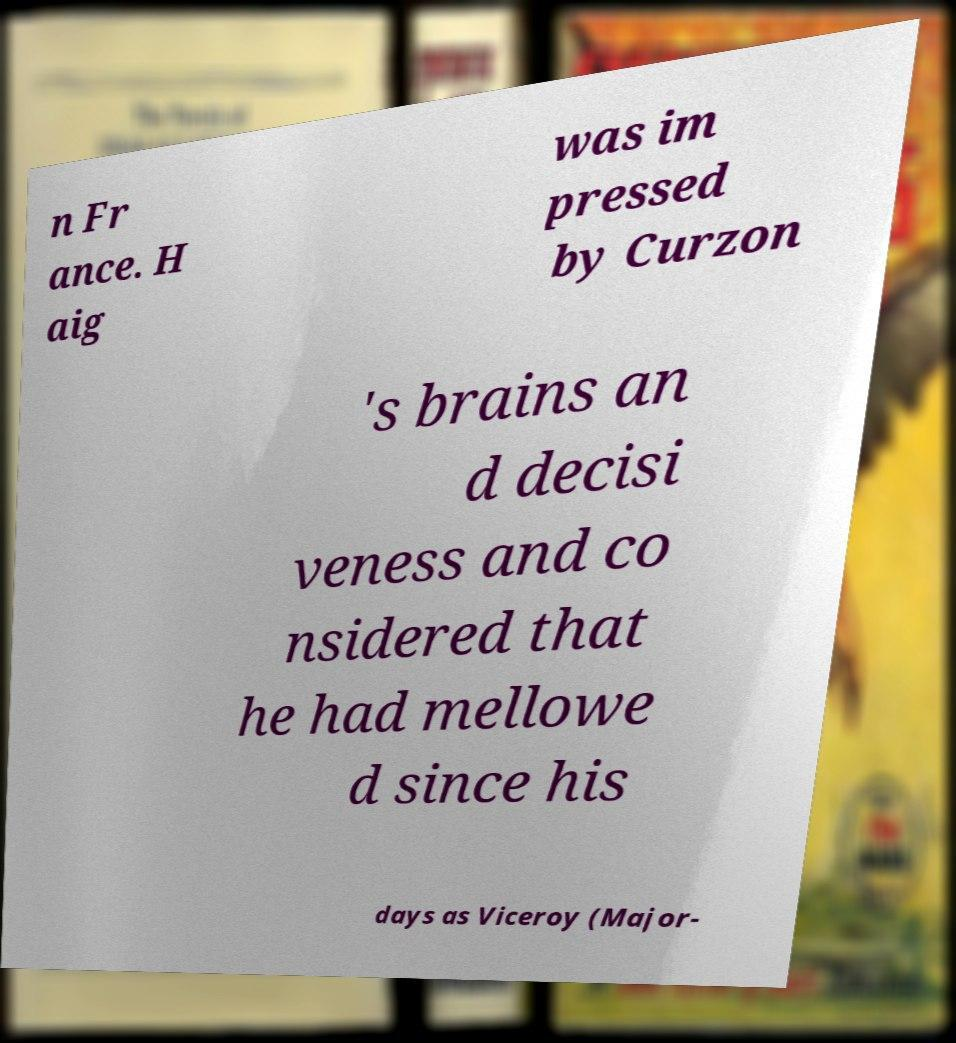Could you extract and type out the text from this image? n Fr ance. H aig was im pressed by Curzon 's brains an d decisi veness and co nsidered that he had mellowe d since his days as Viceroy (Major- 